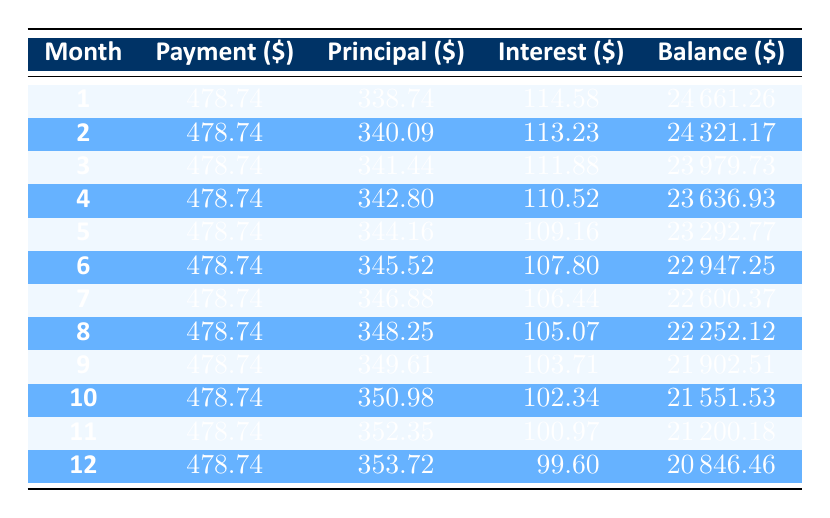What is the monthly payment for the car loan? The monthly payment is clearly stated in the table, and it is listed as 478.74.
Answer: 478.74 In the first month, how much of the payment went towards the principal? According to the first row of the table, the principal payment in the first month is 338.74.
Answer: 338.74 What is the balance after the 12th payment? The balance after the 12th payment is found in the last row of the table, which shows the balance as 20846.46.
Answer: 20846.46 What is the total interest paid in the first three months? To find the total interest for the first three months, I will sum the interest values from the first three rows: 114.58 + 113.23 + 111.88 = 339.69.
Answer: 339.69 Does the interest decrease over the course of the payments? By observing the interest amounts in each month, it is evident that they gradually decrease each month.
Answer: Yes What is the difference in the principal payment between the 1st and 6th month? The principal payment in the 1st month is 338.74 and in the 6th month, it is 345.52. The difference is 345.52 - 338.74 = 6.78.
Answer: 6.78 What is the average payment towards the principal for the first 12 months? To find this, I will sum the principals for all 12 months and divide by 12. The total of all principal payments is 338.74 + 340.09 + 341.44 + 342.80 + 344.16 + 345.52 + 346.88 + 348.25 + 349.61 + 350.98 + 352.35 + 353.72 = 4149.63. Thus, the average is 4149.63 / 12 = 345.80.
Answer: 345.80 How much was the total payment made in the 12th month? The total payment for the 12th month, as seen in the table, is 478.74, which is consistent across all months.
Answer: 478.74 What is the highest principal payment within the first three months? Examining the principal payments for the first three months (338.74, 340.09, 341.44), the highest value is 341.44, which is in the third month.
Answer: 341.44 